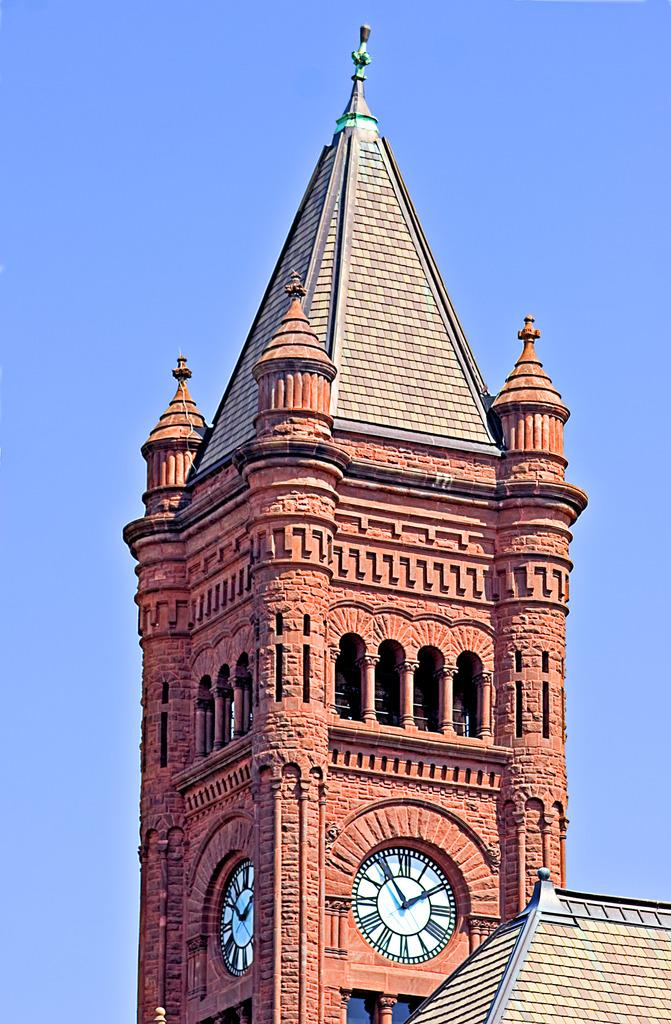What type of structure is present in the image? There is a building in the image. What object can be seen on the building? There is a clock in the image. What can be seen in the background of the image? The sky is visible in the image. What type of power is being generated by the building in the image? There is no information about power generation in the image; it only shows a building and a clock. 